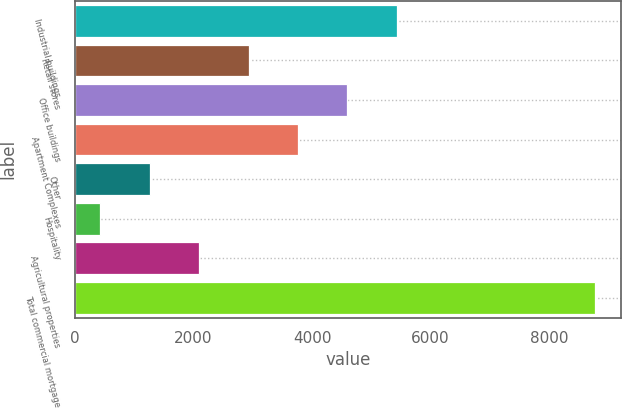Convert chart. <chart><loc_0><loc_0><loc_500><loc_500><bar_chart><fcel>Industrial buildings<fcel>Retail stores<fcel>Office buildings<fcel>Apartment Complexes<fcel>Other<fcel>Hospitality<fcel>Agricultural properties<fcel>Total commercial mortgage<nl><fcel>5429.8<fcel>2928.4<fcel>4596<fcel>3762.2<fcel>1260.8<fcel>427<fcel>2094.6<fcel>8765<nl></chart> 